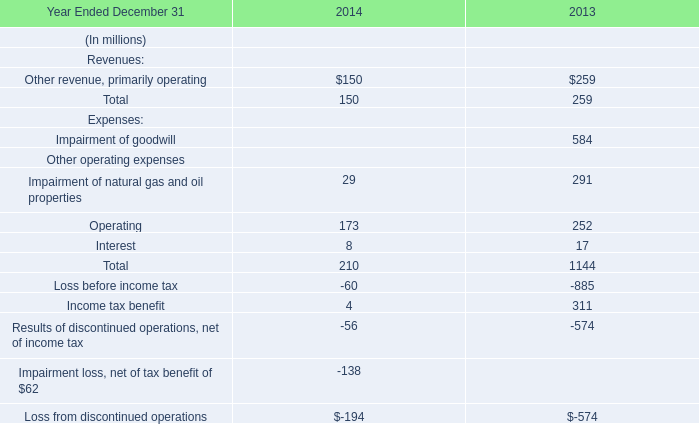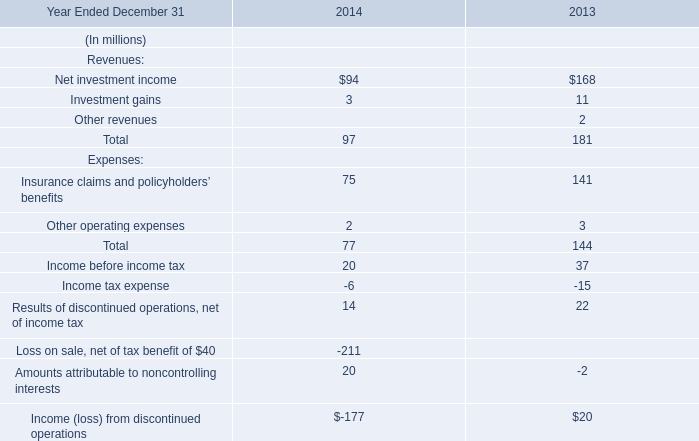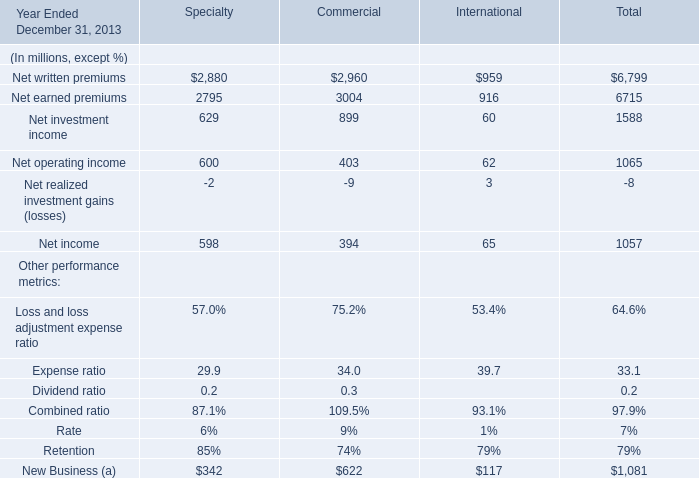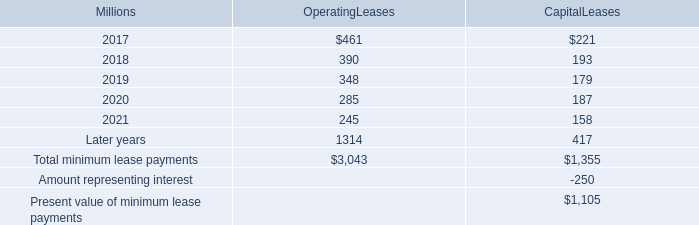the total minimum payments for operating leases is what percentage of total minimum payments for capital leases? 
Computations: ((3043 / 1355) * 100)
Answer: 224.57565. 